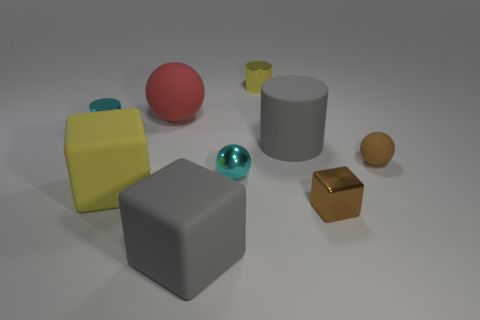Subtract all metal spheres. How many spheres are left? 2 Subtract all cyan balls. How many balls are left? 2 Subtract all cubes. How many objects are left? 6 Subtract 2 spheres. How many spheres are left? 1 Subtract all green spheres. Subtract all purple cylinders. How many spheres are left? 3 Subtract 0 purple cylinders. How many objects are left? 9 Subtract all red cubes. Subtract all small cyan balls. How many objects are left? 8 Add 9 yellow blocks. How many yellow blocks are left? 10 Add 2 cubes. How many cubes exist? 5 